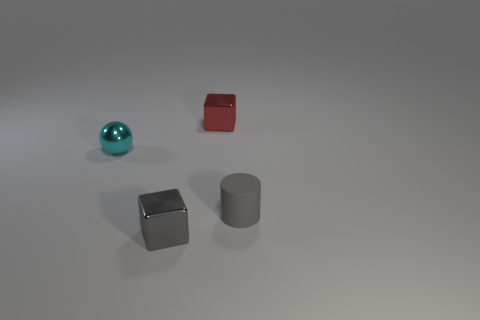Add 3 red metallic things. How many objects exist? 7 Subtract all gray blocks. How many blocks are left? 1 Subtract all spheres. How many objects are left? 3 Subtract 1 blocks. How many blocks are left? 1 Subtract 1 gray blocks. How many objects are left? 3 Subtract all gray spheres. Subtract all gray cubes. How many spheres are left? 1 Subtract all purple blocks. How many green cylinders are left? 0 Subtract all gray metallic things. Subtract all gray metal cubes. How many objects are left? 2 Add 2 red metallic objects. How many red metallic objects are left? 3 Add 1 big gray metal objects. How many big gray metal objects exist? 1 